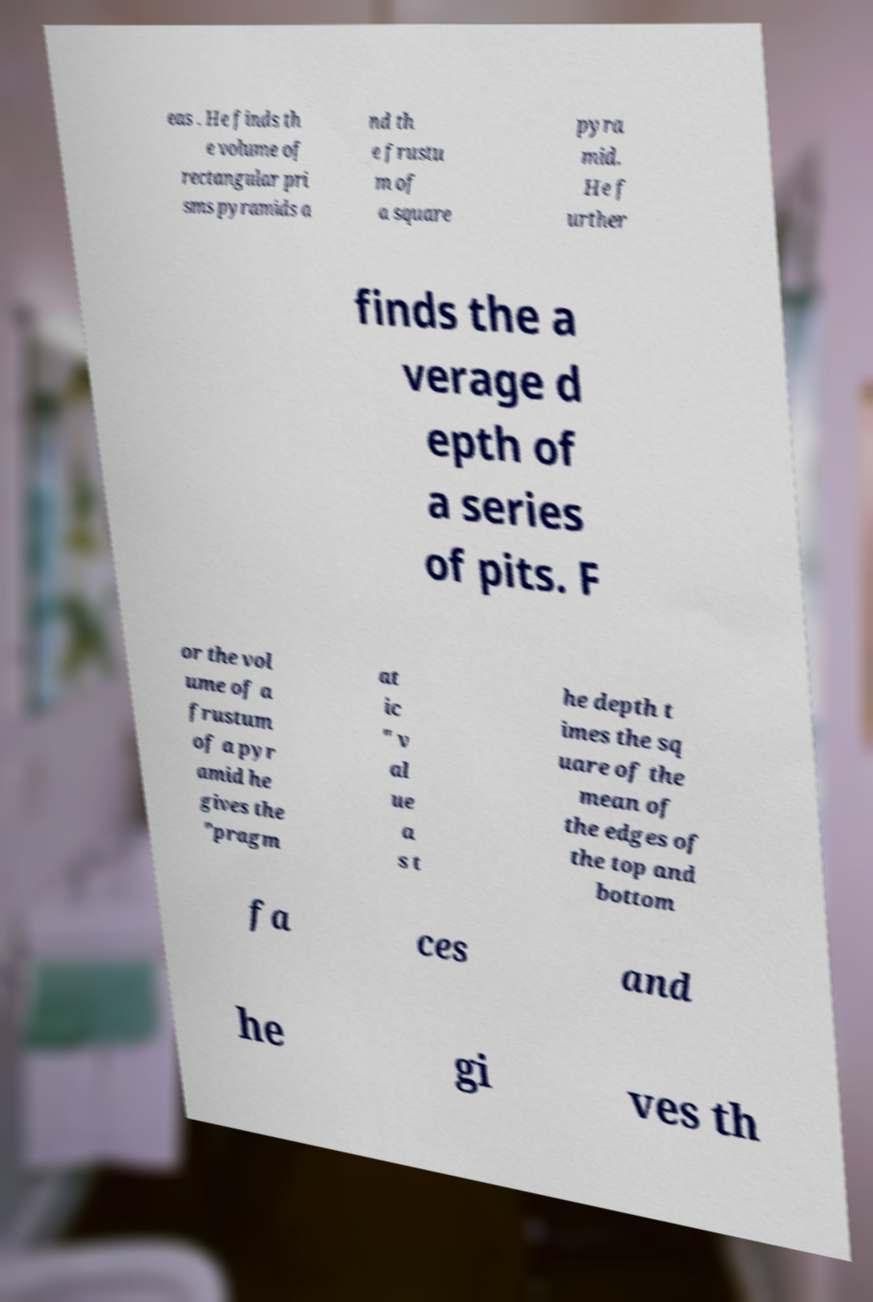Can you accurately transcribe the text from the provided image for me? eas . He finds th e volume of rectangular pri sms pyramids a nd th e frustu m of a square pyra mid. He f urther finds the a verage d epth of a series of pits. F or the vol ume of a frustum of a pyr amid he gives the "pragm at ic " v al ue a s t he depth t imes the sq uare of the mean of the edges of the top and bottom fa ces and he gi ves th 